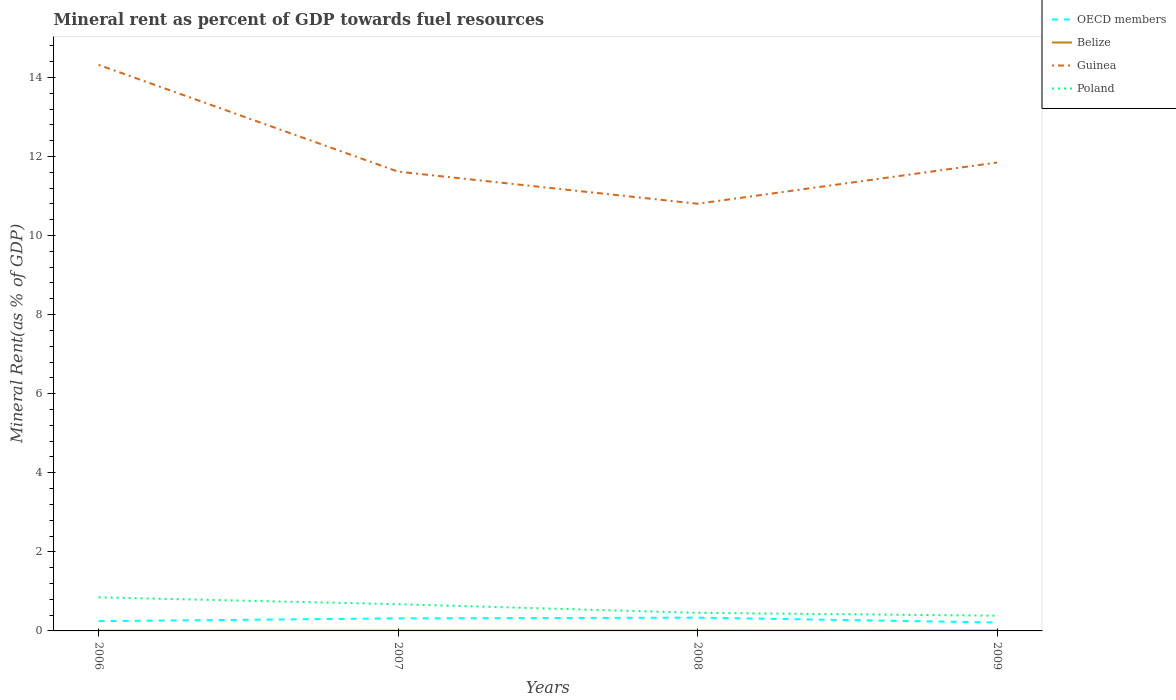Across all years, what is the maximum mineral rent in Guinea?
Give a very brief answer. 10.8. What is the total mineral rent in OECD members in the graph?
Make the answer very short. -0.09. What is the difference between the highest and the second highest mineral rent in OECD members?
Make the answer very short. 0.12. Is the mineral rent in OECD members strictly greater than the mineral rent in Belize over the years?
Your answer should be very brief. No. What is the difference between two consecutive major ticks on the Y-axis?
Keep it short and to the point. 2. Does the graph contain grids?
Your answer should be very brief. No. Where does the legend appear in the graph?
Make the answer very short. Top right. What is the title of the graph?
Make the answer very short. Mineral rent as percent of GDP towards fuel resources. Does "Guinea" appear as one of the legend labels in the graph?
Your answer should be compact. Yes. What is the label or title of the X-axis?
Offer a terse response. Years. What is the label or title of the Y-axis?
Ensure brevity in your answer.  Mineral Rent(as % of GDP). What is the Mineral Rent(as % of GDP) of OECD members in 2006?
Provide a succinct answer. 0.25. What is the Mineral Rent(as % of GDP) of Belize in 2006?
Offer a very short reply. 0. What is the Mineral Rent(as % of GDP) of Guinea in 2006?
Keep it short and to the point. 14.32. What is the Mineral Rent(as % of GDP) of Poland in 2006?
Offer a terse response. 0.85. What is the Mineral Rent(as % of GDP) in OECD members in 2007?
Your answer should be compact. 0.32. What is the Mineral Rent(as % of GDP) of Belize in 2007?
Keep it short and to the point. 0. What is the Mineral Rent(as % of GDP) in Guinea in 2007?
Your response must be concise. 11.62. What is the Mineral Rent(as % of GDP) in Poland in 2007?
Provide a succinct answer. 0.68. What is the Mineral Rent(as % of GDP) in OECD members in 2008?
Give a very brief answer. 0.34. What is the Mineral Rent(as % of GDP) of Belize in 2008?
Make the answer very short. 0.01. What is the Mineral Rent(as % of GDP) of Guinea in 2008?
Give a very brief answer. 10.8. What is the Mineral Rent(as % of GDP) in Poland in 2008?
Your answer should be compact. 0.46. What is the Mineral Rent(as % of GDP) of OECD members in 2009?
Keep it short and to the point. 0.21. What is the Mineral Rent(as % of GDP) in Belize in 2009?
Ensure brevity in your answer.  0.01. What is the Mineral Rent(as % of GDP) in Guinea in 2009?
Offer a very short reply. 11.85. What is the Mineral Rent(as % of GDP) of Poland in 2009?
Your answer should be compact. 0.39. Across all years, what is the maximum Mineral Rent(as % of GDP) in OECD members?
Provide a succinct answer. 0.34. Across all years, what is the maximum Mineral Rent(as % of GDP) of Belize?
Ensure brevity in your answer.  0.01. Across all years, what is the maximum Mineral Rent(as % of GDP) of Guinea?
Your answer should be very brief. 14.32. Across all years, what is the maximum Mineral Rent(as % of GDP) in Poland?
Provide a succinct answer. 0.85. Across all years, what is the minimum Mineral Rent(as % of GDP) of OECD members?
Keep it short and to the point. 0.21. Across all years, what is the minimum Mineral Rent(as % of GDP) of Belize?
Make the answer very short. 0. Across all years, what is the minimum Mineral Rent(as % of GDP) of Guinea?
Offer a very short reply. 10.8. Across all years, what is the minimum Mineral Rent(as % of GDP) in Poland?
Offer a very short reply. 0.39. What is the total Mineral Rent(as % of GDP) in OECD members in the graph?
Your answer should be compact. 1.11. What is the total Mineral Rent(as % of GDP) of Belize in the graph?
Ensure brevity in your answer.  0.02. What is the total Mineral Rent(as % of GDP) in Guinea in the graph?
Offer a terse response. 48.58. What is the total Mineral Rent(as % of GDP) in Poland in the graph?
Your answer should be compact. 2.37. What is the difference between the Mineral Rent(as % of GDP) in OECD members in 2006 and that in 2007?
Keep it short and to the point. -0.07. What is the difference between the Mineral Rent(as % of GDP) in Belize in 2006 and that in 2007?
Your answer should be compact. -0. What is the difference between the Mineral Rent(as % of GDP) of Guinea in 2006 and that in 2007?
Your answer should be compact. 2.7. What is the difference between the Mineral Rent(as % of GDP) of Poland in 2006 and that in 2007?
Your answer should be very brief. 0.17. What is the difference between the Mineral Rent(as % of GDP) of OECD members in 2006 and that in 2008?
Your answer should be very brief. -0.09. What is the difference between the Mineral Rent(as % of GDP) of Belize in 2006 and that in 2008?
Provide a succinct answer. -0. What is the difference between the Mineral Rent(as % of GDP) of Guinea in 2006 and that in 2008?
Give a very brief answer. 3.51. What is the difference between the Mineral Rent(as % of GDP) in Poland in 2006 and that in 2008?
Offer a terse response. 0.39. What is the difference between the Mineral Rent(as % of GDP) of OECD members in 2006 and that in 2009?
Provide a succinct answer. 0.03. What is the difference between the Mineral Rent(as % of GDP) in Belize in 2006 and that in 2009?
Make the answer very short. -0. What is the difference between the Mineral Rent(as % of GDP) of Guinea in 2006 and that in 2009?
Offer a terse response. 2.47. What is the difference between the Mineral Rent(as % of GDP) of Poland in 2006 and that in 2009?
Provide a succinct answer. 0.46. What is the difference between the Mineral Rent(as % of GDP) in OECD members in 2007 and that in 2008?
Provide a succinct answer. -0.02. What is the difference between the Mineral Rent(as % of GDP) of Belize in 2007 and that in 2008?
Provide a succinct answer. -0. What is the difference between the Mineral Rent(as % of GDP) in Guinea in 2007 and that in 2008?
Your answer should be very brief. 0.81. What is the difference between the Mineral Rent(as % of GDP) of Poland in 2007 and that in 2008?
Your answer should be very brief. 0.22. What is the difference between the Mineral Rent(as % of GDP) of OECD members in 2007 and that in 2009?
Give a very brief answer. 0.1. What is the difference between the Mineral Rent(as % of GDP) in Belize in 2007 and that in 2009?
Your response must be concise. -0. What is the difference between the Mineral Rent(as % of GDP) of Guinea in 2007 and that in 2009?
Provide a short and direct response. -0.23. What is the difference between the Mineral Rent(as % of GDP) in Poland in 2007 and that in 2009?
Ensure brevity in your answer.  0.29. What is the difference between the Mineral Rent(as % of GDP) of OECD members in 2008 and that in 2009?
Offer a terse response. 0.12. What is the difference between the Mineral Rent(as % of GDP) in Belize in 2008 and that in 2009?
Make the answer very short. -0. What is the difference between the Mineral Rent(as % of GDP) in Guinea in 2008 and that in 2009?
Offer a terse response. -1.04. What is the difference between the Mineral Rent(as % of GDP) in Poland in 2008 and that in 2009?
Offer a very short reply. 0.07. What is the difference between the Mineral Rent(as % of GDP) of OECD members in 2006 and the Mineral Rent(as % of GDP) of Belize in 2007?
Provide a short and direct response. 0.24. What is the difference between the Mineral Rent(as % of GDP) in OECD members in 2006 and the Mineral Rent(as % of GDP) in Guinea in 2007?
Your answer should be compact. -11.37. What is the difference between the Mineral Rent(as % of GDP) of OECD members in 2006 and the Mineral Rent(as % of GDP) of Poland in 2007?
Provide a short and direct response. -0.43. What is the difference between the Mineral Rent(as % of GDP) of Belize in 2006 and the Mineral Rent(as % of GDP) of Guinea in 2007?
Your answer should be compact. -11.61. What is the difference between the Mineral Rent(as % of GDP) in Belize in 2006 and the Mineral Rent(as % of GDP) in Poland in 2007?
Your response must be concise. -0.67. What is the difference between the Mineral Rent(as % of GDP) in Guinea in 2006 and the Mineral Rent(as % of GDP) in Poland in 2007?
Provide a short and direct response. 13.64. What is the difference between the Mineral Rent(as % of GDP) of OECD members in 2006 and the Mineral Rent(as % of GDP) of Belize in 2008?
Your answer should be compact. 0.24. What is the difference between the Mineral Rent(as % of GDP) of OECD members in 2006 and the Mineral Rent(as % of GDP) of Guinea in 2008?
Your answer should be compact. -10.56. What is the difference between the Mineral Rent(as % of GDP) in OECD members in 2006 and the Mineral Rent(as % of GDP) in Poland in 2008?
Your response must be concise. -0.21. What is the difference between the Mineral Rent(as % of GDP) in Belize in 2006 and the Mineral Rent(as % of GDP) in Guinea in 2008?
Provide a succinct answer. -10.8. What is the difference between the Mineral Rent(as % of GDP) in Belize in 2006 and the Mineral Rent(as % of GDP) in Poland in 2008?
Your response must be concise. -0.45. What is the difference between the Mineral Rent(as % of GDP) in Guinea in 2006 and the Mineral Rent(as % of GDP) in Poland in 2008?
Provide a short and direct response. 13.86. What is the difference between the Mineral Rent(as % of GDP) in OECD members in 2006 and the Mineral Rent(as % of GDP) in Belize in 2009?
Keep it short and to the point. 0.24. What is the difference between the Mineral Rent(as % of GDP) of OECD members in 2006 and the Mineral Rent(as % of GDP) of Guinea in 2009?
Your response must be concise. -11.6. What is the difference between the Mineral Rent(as % of GDP) of OECD members in 2006 and the Mineral Rent(as % of GDP) of Poland in 2009?
Provide a succinct answer. -0.14. What is the difference between the Mineral Rent(as % of GDP) in Belize in 2006 and the Mineral Rent(as % of GDP) in Guinea in 2009?
Provide a succinct answer. -11.84. What is the difference between the Mineral Rent(as % of GDP) of Belize in 2006 and the Mineral Rent(as % of GDP) of Poland in 2009?
Provide a short and direct response. -0.38. What is the difference between the Mineral Rent(as % of GDP) of Guinea in 2006 and the Mineral Rent(as % of GDP) of Poland in 2009?
Keep it short and to the point. 13.93. What is the difference between the Mineral Rent(as % of GDP) in OECD members in 2007 and the Mineral Rent(as % of GDP) in Belize in 2008?
Provide a short and direct response. 0.31. What is the difference between the Mineral Rent(as % of GDP) in OECD members in 2007 and the Mineral Rent(as % of GDP) in Guinea in 2008?
Keep it short and to the point. -10.49. What is the difference between the Mineral Rent(as % of GDP) in OECD members in 2007 and the Mineral Rent(as % of GDP) in Poland in 2008?
Your answer should be compact. -0.14. What is the difference between the Mineral Rent(as % of GDP) in Belize in 2007 and the Mineral Rent(as % of GDP) in Guinea in 2008?
Make the answer very short. -10.8. What is the difference between the Mineral Rent(as % of GDP) in Belize in 2007 and the Mineral Rent(as % of GDP) in Poland in 2008?
Keep it short and to the point. -0.45. What is the difference between the Mineral Rent(as % of GDP) of Guinea in 2007 and the Mineral Rent(as % of GDP) of Poland in 2008?
Provide a short and direct response. 11.16. What is the difference between the Mineral Rent(as % of GDP) in OECD members in 2007 and the Mineral Rent(as % of GDP) in Belize in 2009?
Provide a succinct answer. 0.31. What is the difference between the Mineral Rent(as % of GDP) in OECD members in 2007 and the Mineral Rent(as % of GDP) in Guinea in 2009?
Provide a succinct answer. -11.53. What is the difference between the Mineral Rent(as % of GDP) in OECD members in 2007 and the Mineral Rent(as % of GDP) in Poland in 2009?
Give a very brief answer. -0.07. What is the difference between the Mineral Rent(as % of GDP) of Belize in 2007 and the Mineral Rent(as % of GDP) of Guinea in 2009?
Your answer should be compact. -11.84. What is the difference between the Mineral Rent(as % of GDP) in Belize in 2007 and the Mineral Rent(as % of GDP) in Poland in 2009?
Offer a terse response. -0.38. What is the difference between the Mineral Rent(as % of GDP) of Guinea in 2007 and the Mineral Rent(as % of GDP) of Poland in 2009?
Keep it short and to the point. 11.23. What is the difference between the Mineral Rent(as % of GDP) of OECD members in 2008 and the Mineral Rent(as % of GDP) of Belize in 2009?
Ensure brevity in your answer.  0.33. What is the difference between the Mineral Rent(as % of GDP) of OECD members in 2008 and the Mineral Rent(as % of GDP) of Guinea in 2009?
Keep it short and to the point. -11.51. What is the difference between the Mineral Rent(as % of GDP) in OECD members in 2008 and the Mineral Rent(as % of GDP) in Poland in 2009?
Provide a succinct answer. -0.05. What is the difference between the Mineral Rent(as % of GDP) of Belize in 2008 and the Mineral Rent(as % of GDP) of Guinea in 2009?
Make the answer very short. -11.84. What is the difference between the Mineral Rent(as % of GDP) in Belize in 2008 and the Mineral Rent(as % of GDP) in Poland in 2009?
Keep it short and to the point. -0.38. What is the difference between the Mineral Rent(as % of GDP) in Guinea in 2008 and the Mineral Rent(as % of GDP) in Poland in 2009?
Your response must be concise. 10.42. What is the average Mineral Rent(as % of GDP) in OECD members per year?
Keep it short and to the point. 0.28. What is the average Mineral Rent(as % of GDP) of Belize per year?
Offer a very short reply. 0.01. What is the average Mineral Rent(as % of GDP) of Guinea per year?
Your answer should be compact. 12.15. What is the average Mineral Rent(as % of GDP) in Poland per year?
Offer a terse response. 0.59. In the year 2006, what is the difference between the Mineral Rent(as % of GDP) in OECD members and Mineral Rent(as % of GDP) in Belize?
Provide a short and direct response. 0.24. In the year 2006, what is the difference between the Mineral Rent(as % of GDP) of OECD members and Mineral Rent(as % of GDP) of Guinea?
Your response must be concise. -14.07. In the year 2006, what is the difference between the Mineral Rent(as % of GDP) of OECD members and Mineral Rent(as % of GDP) of Poland?
Give a very brief answer. -0.6. In the year 2006, what is the difference between the Mineral Rent(as % of GDP) of Belize and Mineral Rent(as % of GDP) of Guinea?
Offer a very short reply. -14.31. In the year 2006, what is the difference between the Mineral Rent(as % of GDP) in Belize and Mineral Rent(as % of GDP) in Poland?
Your response must be concise. -0.85. In the year 2006, what is the difference between the Mineral Rent(as % of GDP) in Guinea and Mineral Rent(as % of GDP) in Poland?
Provide a short and direct response. 13.47. In the year 2007, what is the difference between the Mineral Rent(as % of GDP) in OECD members and Mineral Rent(as % of GDP) in Belize?
Offer a terse response. 0.31. In the year 2007, what is the difference between the Mineral Rent(as % of GDP) of OECD members and Mineral Rent(as % of GDP) of Guinea?
Give a very brief answer. -11.3. In the year 2007, what is the difference between the Mineral Rent(as % of GDP) of OECD members and Mineral Rent(as % of GDP) of Poland?
Provide a short and direct response. -0.36. In the year 2007, what is the difference between the Mineral Rent(as % of GDP) of Belize and Mineral Rent(as % of GDP) of Guinea?
Make the answer very short. -11.61. In the year 2007, what is the difference between the Mineral Rent(as % of GDP) of Belize and Mineral Rent(as % of GDP) of Poland?
Offer a terse response. -0.67. In the year 2007, what is the difference between the Mineral Rent(as % of GDP) in Guinea and Mineral Rent(as % of GDP) in Poland?
Ensure brevity in your answer.  10.94. In the year 2008, what is the difference between the Mineral Rent(as % of GDP) of OECD members and Mineral Rent(as % of GDP) of Belize?
Give a very brief answer. 0.33. In the year 2008, what is the difference between the Mineral Rent(as % of GDP) in OECD members and Mineral Rent(as % of GDP) in Guinea?
Make the answer very short. -10.47. In the year 2008, what is the difference between the Mineral Rent(as % of GDP) of OECD members and Mineral Rent(as % of GDP) of Poland?
Your answer should be compact. -0.12. In the year 2008, what is the difference between the Mineral Rent(as % of GDP) in Belize and Mineral Rent(as % of GDP) in Guinea?
Give a very brief answer. -10.8. In the year 2008, what is the difference between the Mineral Rent(as % of GDP) in Belize and Mineral Rent(as % of GDP) in Poland?
Give a very brief answer. -0.45. In the year 2008, what is the difference between the Mineral Rent(as % of GDP) in Guinea and Mineral Rent(as % of GDP) in Poland?
Keep it short and to the point. 10.35. In the year 2009, what is the difference between the Mineral Rent(as % of GDP) of OECD members and Mineral Rent(as % of GDP) of Belize?
Your answer should be compact. 0.21. In the year 2009, what is the difference between the Mineral Rent(as % of GDP) in OECD members and Mineral Rent(as % of GDP) in Guinea?
Offer a terse response. -11.63. In the year 2009, what is the difference between the Mineral Rent(as % of GDP) in OECD members and Mineral Rent(as % of GDP) in Poland?
Your response must be concise. -0.17. In the year 2009, what is the difference between the Mineral Rent(as % of GDP) of Belize and Mineral Rent(as % of GDP) of Guinea?
Offer a terse response. -11.84. In the year 2009, what is the difference between the Mineral Rent(as % of GDP) in Belize and Mineral Rent(as % of GDP) in Poland?
Keep it short and to the point. -0.38. In the year 2009, what is the difference between the Mineral Rent(as % of GDP) of Guinea and Mineral Rent(as % of GDP) of Poland?
Ensure brevity in your answer.  11.46. What is the ratio of the Mineral Rent(as % of GDP) in OECD members in 2006 to that in 2007?
Ensure brevity in your answer.  0.78. What is the ratio of the Mineral Rent(as % of GDP) in Belize in 2006 to that in 2007?
Provide a succinct answer. 0.85. What is the ratio of the Mineral Rent(as % of GDP) of Guinea in 2006 to that in 2007?
Your response must be concise. 1.23. What is the ratio of the Mineral Rent(as % of GDP) of Poland in 2006 to that in 2007?
Your answer should be very brief. 1.26. What is the ratio of the Mineral Rent(as % of GDP) of OECD members in 2006 to that in 2008?
Your response must be concise. 0.74. What is the ratio of the Mineral Rent(as % of GDP) of Belize in 2006 to that in 2008?
Make the answer very short. 0.64. What is the ratio of the Mineral Rent(as % of GDP) in Guinea in 2006 to that in 2008?
Keep it short and to the point. 1.33. What is the ratio of the Mineral Rent(as % of GDP) of Poland in 2006 to that in 2008?
Offer a terse response. 1.86. What is the ratio of the Mineral Rent(as % of GDP) of OECD members in 2006 to that in 2009?
Provide a short and direct response. 1.16. What is the ratio of the Mineral Rent(as % of GDP) of Belize in 2006 to that in 2009?
Provide a short and direct response. 0.5. What is the ratio of the Mineral Rent(as % of GDP) in Guinea in 2006 to that in 2009?
Ensure brevity in your answer.  1.21. What is the ratio of the Mineral Rent(as % of GDP) in Poland in 2006 to that in 2009?
Provide a short and direct response. 2.21. What is the ratio of the Mineral Rent(as % of GDP) in OECD members in 2007 to that in 2008?
Offer a very short reply. 0.95. What is the ratio of the Mineral Rent(as % of GDP) in Belize in 2007 to that in 2008?
Your response must be concise. 0.75. What is the ratio of the Mineral Rent(as % of GDP) of Guinea in 2007 to that in 2008?
Provide a succinct answer. 1.08. What is the ratio of the Mineral Rent(as % of GDP) of Poland in 2007 to that in 2008?
Offer a very short reply. 1.48. What is the ratio of the Mineral Rent(as % of GDP) of OECD members in 2007 to that in 2009?
Give a very brief answer. 1.49. What is the ratio of the Mineral Rent(as % of GDP) of Belize in 2007 to that in 2009?
Ensure brevity in your answer.  0.59. What is the ratio of the Mineral Rent(as % of GDP) in Guinea in 2007 to that in 2009?
Offer a terse response. 0.98. What is the ratio of the Mineral Rent(as % of GDP) in Poland in 2007 to that in 2009?
Keep it short and to the point. 1.75. What is the ratio of the Mineral Rent(as % of GDP) of OECD members in 2008 to that in 2009?
Keep it short and to the point. 1.57. What is the ratio of the Mineral Rent(as % of GDP) in Belize in 2008 to that in 2009?
Provide a succinct answer. 0.79. What is the ratio of the Mineral Rent(as % of GDP) in Guinea in 2008 to that in 2009?
Your answer should be very brief. 0.91. What is the ratio of the Mineral Rent(as % of GDP) in Poland in 2008 to that in 2009?
Provide a succinct answer. 1.19. What is the difference between the highest and the second highest Mineral Rent(as % of GDP) of OECD members?
Keep it short and to the point. 0.02. What is the difference between the highest and the second highest Mineral Rent(as % of GDP) in Belize?
Provide a succinct answer. 0. What is the difference between the highest and the second highest Mineral Rent(as % of GDP) in Guinea?
Your answer should be very brief. 2.47. What is the difference between the highest and the second highest Mineral Rent(as % of GDP) in Poland?
Ensure brevity in your answer.  0.17. What is the difference between the highest and the lowest Mineral Rent(as % of GDP) of OECD members?
Offer a very short reply. 0.12. What is the difference between the highest and the lowest Mineral Rent(as % of GDP) in Belize?
Provide a succinct answer. 0. What is the difference between the highest and the lowest Mineral Rent(as % of GDP) in Guinea?
Your answer should be compact. 3.51. What is the difference between the highest and the lowest Mineral Rent(as % of GDP) in Poland?
Give a very brief answer. 0.46. 